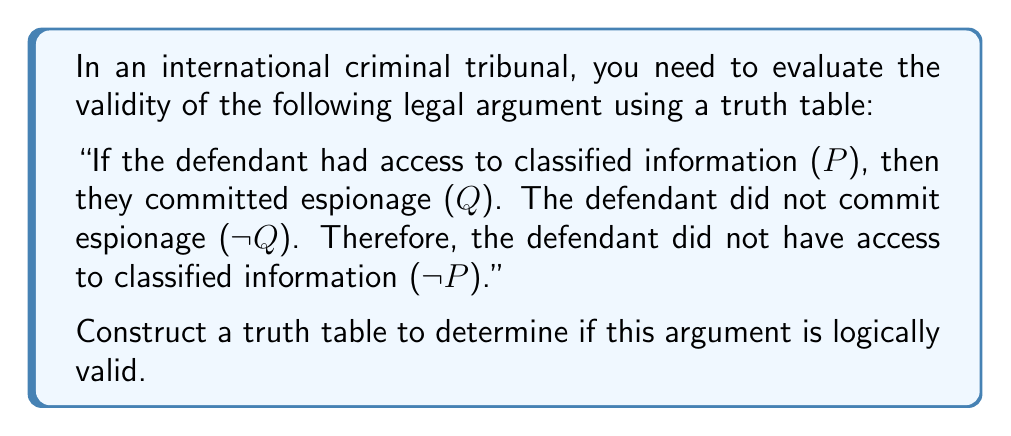Can you solve this math problem? To evaluate the validity of this legal argument, we need to construct a truth table for the given premises and conclusion. The argument can be represented in symbolic logic as:

1. $P \rightarrow Q$ (Premise 1)
2. $\sim Q$ (Premise 2)
3. $\therefore \sim P$ (Conclusion)

Let's construct the truth table:

$$
\begin{array}{|c|c|c|c|c|c|}
\hline
P & Q & P \rightarrow Q & \sim Q & \sim P & \text{Valid?} \\
\hline
T & T & T & F & F & - \\
T & F & F & T & F & \checkmark \\
F & T & T & F & T & - \\
F & F & T & T & T & \checkmark \\
\hline
\end{array}
$$

To determine if the argument is valid, we need to check if there are any rows where both premises are true (columns 3 and 4) but the conclusion is false (column 5).

In the first row, Premise 2 ($\sim Q$) is false, so we don't need to consider this row.
In the second row, both premises are true, and the conclusion is false. This violates the definition of a valid argument.
In the third row, Premise 2 ($\sim Q$) is false, so we don't need to consider this row.
In the fourth row, both premises are true, and the conclusion is also true.

Since we found a row (the second row) where both premises are true but the conclusion is false, this argument is not logically valid. This form of argument is known as the fallacy of denying the antecedent.

In the context of the international criminal tribunal, this means that even if the given premises are true (the link between classified information and espionage, and the fact that the defendant did not commit espionage), it doesn't necessarily follow that the defendant didn't have access to classified information. There could be other reasons why the defendant had access to classified information without committing espionage.
Answer: The argument is not logically valid. The truth table reveals a case where both premises are true, but the conclusion is false, demonstrating the fallacy of denying the antecedent. 